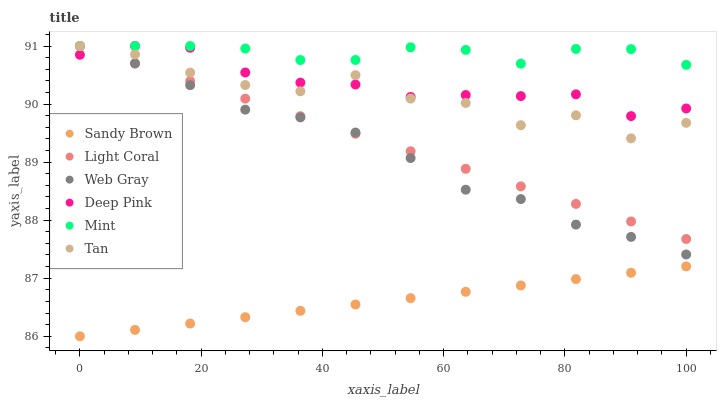Does Sandy Brown have the minimum area under the curve?
Answer yes or no. Yes. Does Mint have the maximum area under the curve?
Answer yes or no. Yes. Does Light Coral have the minimum area under the curve?
Answer yes or no. No. Does Light Coral have the maximum area under the curve?
Answer yes or no. No. Is Light Coral the smoothest?
Answer yes or no. Yes. Is Tan the roughest?
Answer yes or no. Yes. Is Sandy Brown the smoothest?
Answer yes or no. No. Is Sandy Brown the roughest?
Answer yes or no. No. Does Sandy Brown have the lowest value?
Answer yes or no. Yes. Does Light Coral have the lowest value?
Answer yes or no. No. Does Mint have the highest value?
Answer yes or no. Yes. Does Sandy Brown have the highest value?
Answer yes or no. No. Is Sandy Brown less than Deep Pink?
Answer yes or no. Yes. Is Mint greater than Sandy Brown?
Answer yes or no. Yes. Does Light Coral intersect Deep Pink?
Answer yes or no. Yes. Is Light Coral less than Deep Pink?
Answer yes or no. No. Is Light Coral greater than Deep Pink?
Answer yes or no. No. Does Sandy Brown intersect Deep Pink?
Answer yes or no. No. 